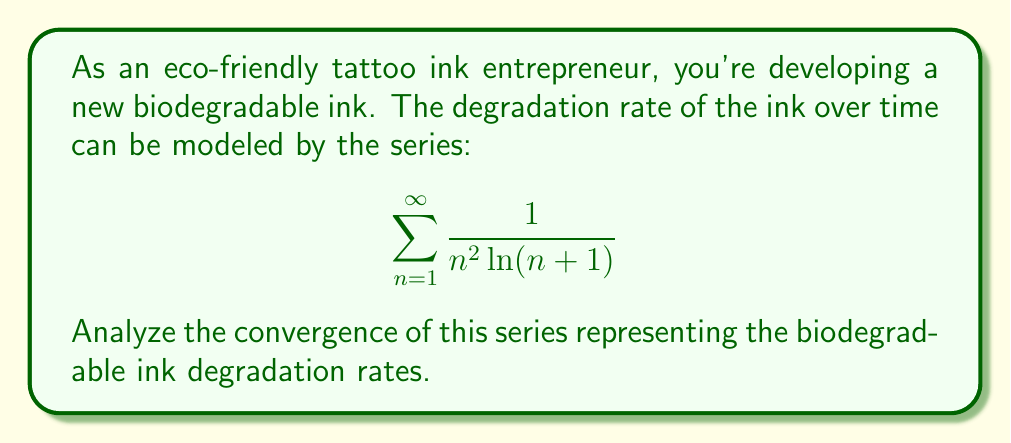Solve this math problem. To analyze the convergence of this series, we'll use the integral test. Let's follow these steps:

1) Define the function $f(x) = \frac{1}{x^2 \ln(x+1)}$ for $x \geq 1$.

2) Check if $f(x)$ is continuous, positive, and decreasing on $[1,\infty)$:
   - $f(x)$ is continuous for $x \geq 1$
   - $f(x) > 0$ for all $x \geq 1$
   - $f'(x) = -\frac{2}{x^3\ln(x+1)} - \frac{1}{x^2(x+1)\ln^2(x+1)} < 0$ for $x \geq 1$, so $f(x)$ is decreasing

3) Apply the integral test:
   $$\int_1^{\infty} \frac{1}{x^2 \ln(x+1)} dx$$

4) Let $u = \ln(x+1)$, then $du = \frac{1}{x+1}dx$ and $x = e^u - 1$

5) Substituting:
   $$\int_{\ln 2}^{\infty} \frac{1}{(e^u-1)^2 u} \cdot (e^u) du = \int_{\ln 2}^{\infty} \frac{e^u}{(e^u-1)^2 u} du$$

6) As $u \to \infty$, $\frac{e^u}{(e^u-1)^2} \to 1$, so for large $u$, our integral behaves like:
   $$\int_{\ln 2}^{\infty} \frac{1}{u} du$$

7) This is a divergent integral (it's the natural log function, which grows without bound).

8) By the integral test, since the integral diverges, the original series also diverges.
Answer: The series diverges. 